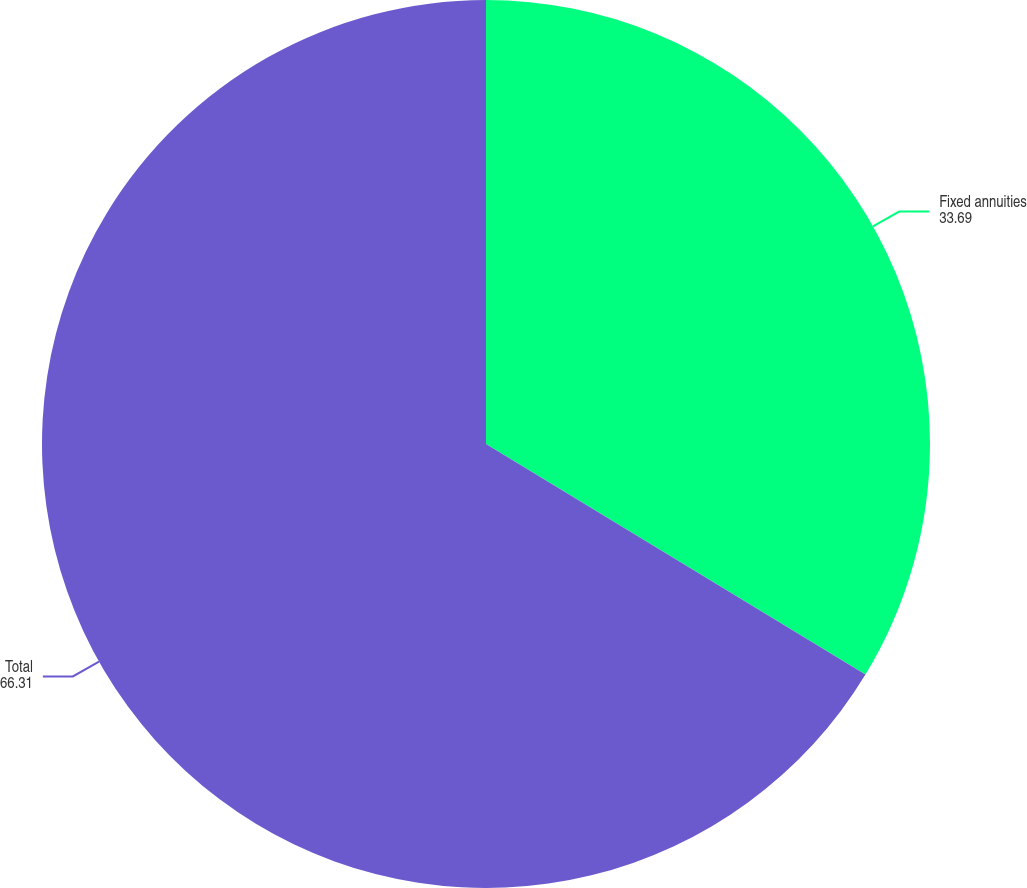Convert chart to OTSL. <chart><loc_0><loc_0><loc_500><loc_500><pie_chart><fcel>Fixed annuities<fcel>Total<nl><fcel>33.69%<fcel>66.31%<nl></chart> 